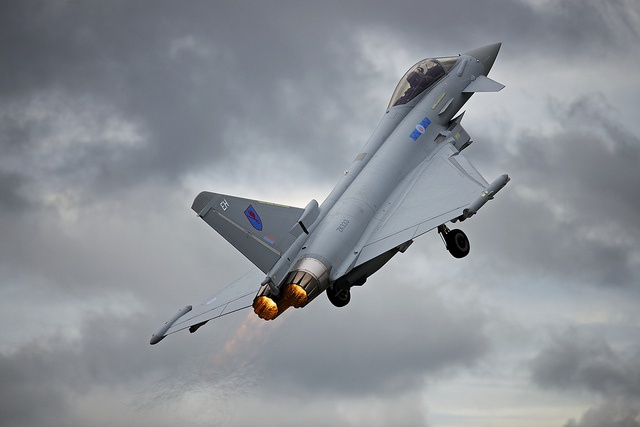Describe the objects in this image and their specific colors. I can see a airplane in gray, darkgray, and black tones in this image. 